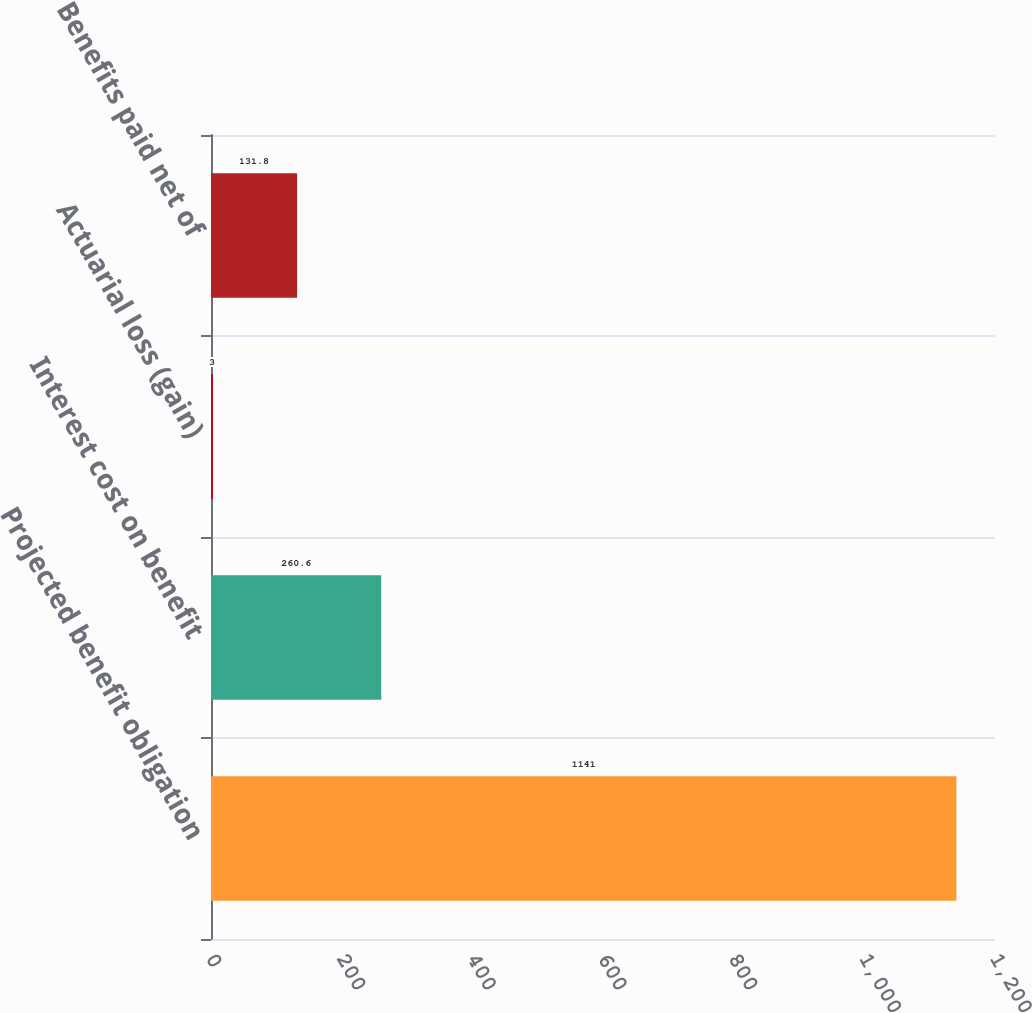<chart> <loc_0><loc_0><loc_500><loc_500><bar_chart><fcel>Projected benefit obligation<fcel>Interest cost on benefit<fcel>Actuarial loss (gain)<fcel>Benefits paid net of<nl><fcel>1141<fcel>260.6<fcel>3<fcel>131.8<nl></chart> 